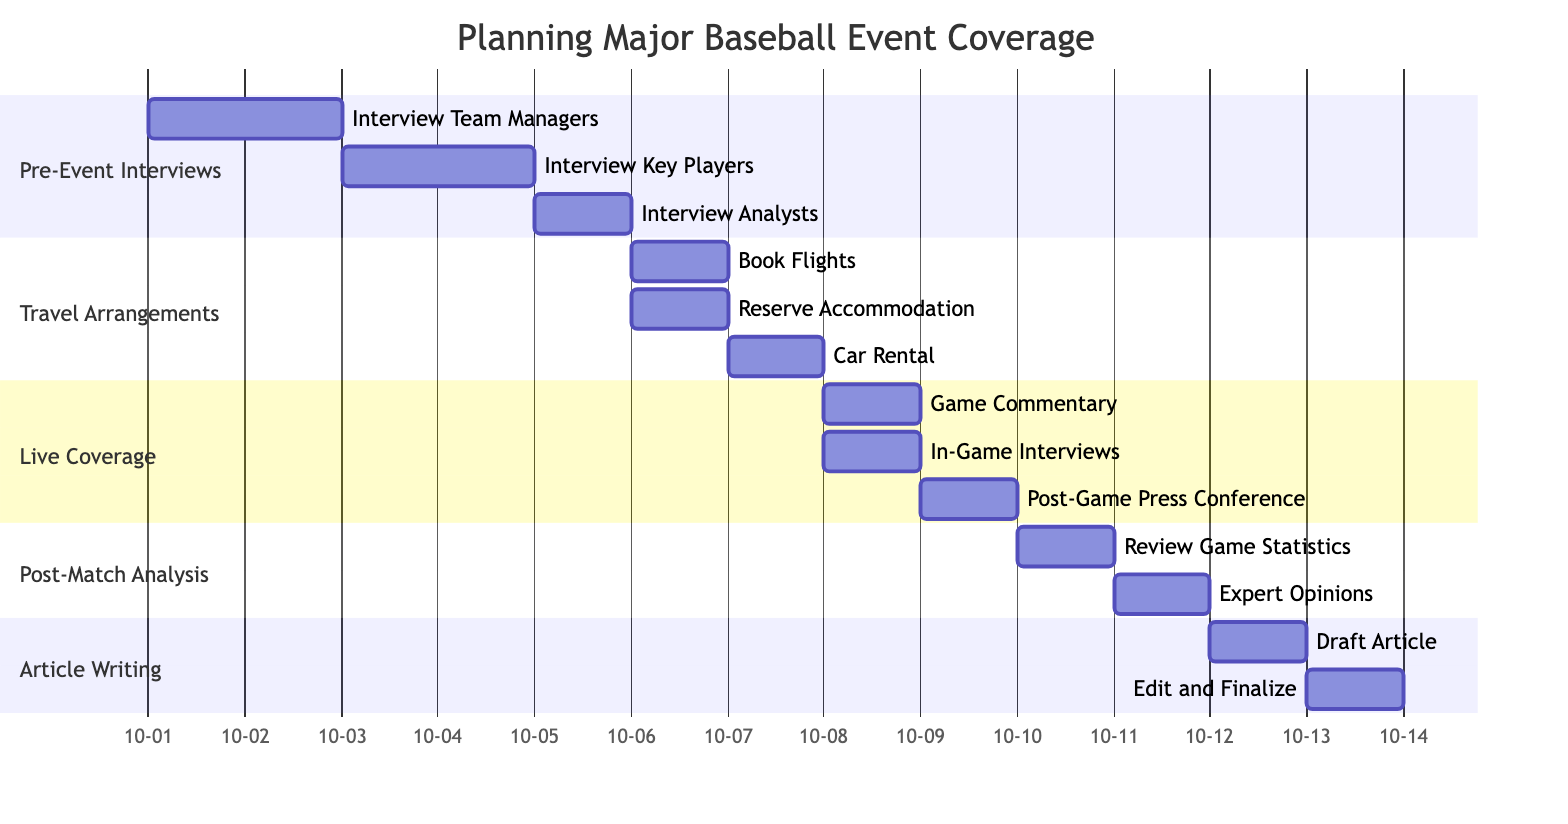What's the duration of "Pre-Event Interviews"? "Pre-Event Interviews" starts on October 1, 2023, and ends on October 5, 2023. The duration is calculated by subtracting the start date from the end date, yielding 5 days.
Answer: 5 days How many subtasks are under "Live Coverage"? "Live Coverage" includes three subtasks: "Game Commentary," "In-Game Interviews," and "Post-Game Press Conference." The count of these subtasks gives the answer.
Answer: 3 What is the start date of "Article Writing"? "Article Writing" starts on October 12, 2023, which is directly listed in the diagram.
Answer: October 12, 2023 Which task involves "Book Flights"? "Book Flights" is a subtask under the "Travel Arrangements" section. The Gantt chart visually groups its subtasks, making it easy to identify its parent task.
Answer: Travel Arrangements What is the end date for the "Expert Opinions" task? The "Expert Opinions" task is marked to end on October 11, 2023. This is stated in the visual representation of the timeline.
Answer: October 11, 2023 Which subtask of "Live Coverage" has the same start date as "In-Game Interviews"? Both "Game Commentary" and "In-Game Interviews" start on the same day, October 8, 2023. The chart shows these tasks aligned on the same date.
Answer: Game Commentary, In-Game Interviews What is the total number of main tasks in the diagram? The diagram lists five main tasks: "Pre-Event Interviews," "Travel Arrangements," "Live Coverage," "Post-Match Analysis," and "Article Writing." The total count of these tasks gives the answer.
Answer: 5 When is "Car Rental" scheduled? "Car Rental" is scheduled for October 7, 2023. This date is clearly indicated in the diagram under the "Travel Arrangements" section.
Answer: October 7, 2023 How many days after "Live Coverage" does "Post-Match Analysis" begin? "Live Coverage" ends on October 9, 2023, and "Post-Match Analysis" begins the next day, October 10, 2023. This is 1 day later.
Answer: 1 day 